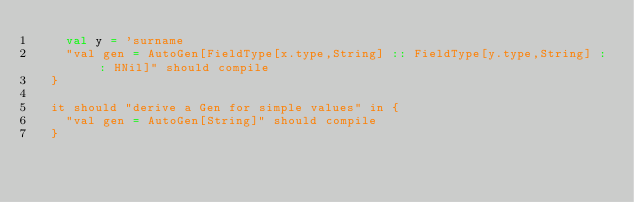<code> <loc_0><loc_0><loc_500><loc_500><_Scala_>    val y = 'surname
    "val gen = AutoGen[FieldType[x.type,String] :: FieldType[y.type,String] :: HNil]" should compile
  }

  it should "derive a Gen for simple values" in {
    "val gen = AutoGen[String]" should compile
  }
</code> 